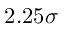<formula> <loc_0><loc_0><loc_500><loc_500>2 . 2 5 \sigma</formula> 